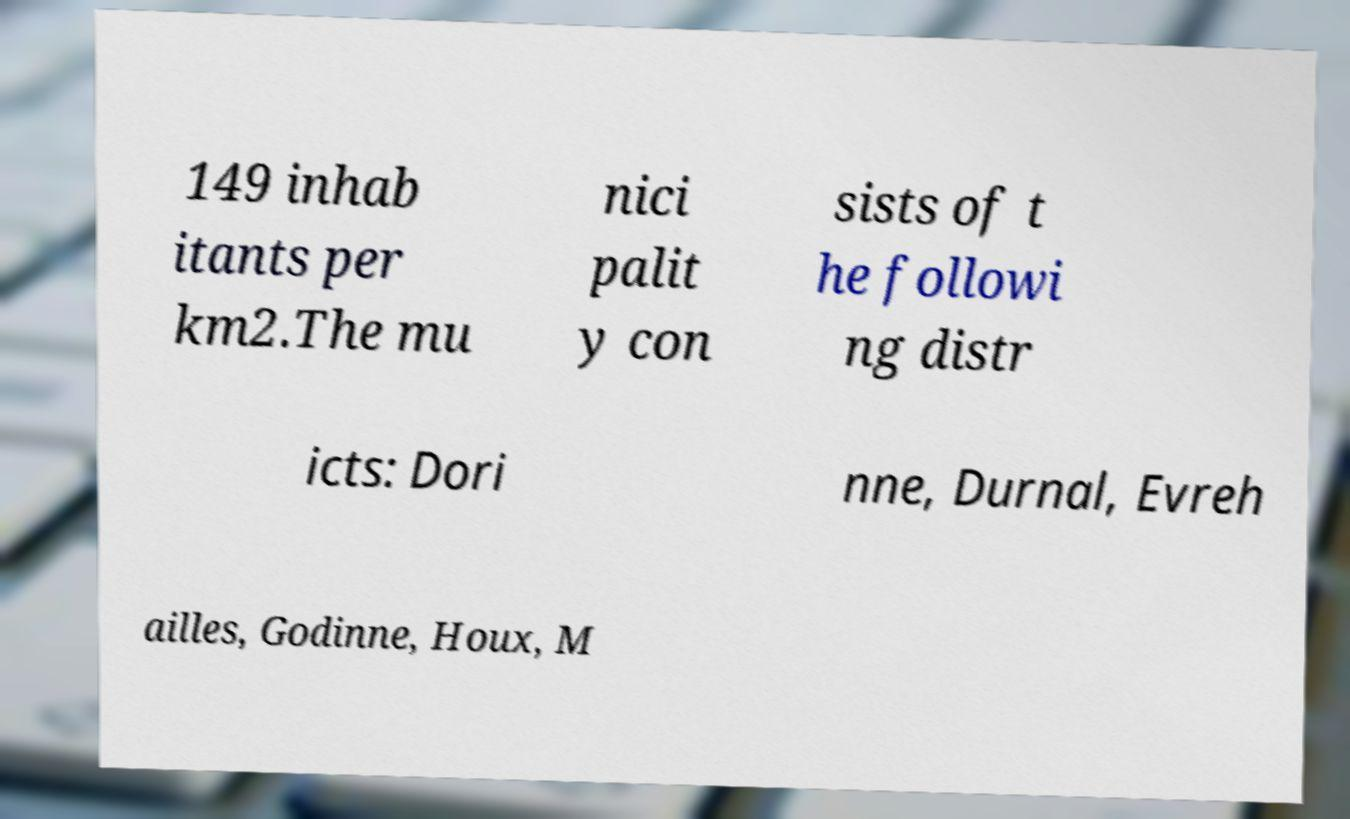Can you read and provide the text displayed in the image?This photo seems to have some interesting text. Can you extract and type it out for me? 149 inhab itants per km2.The mu nici palit y con sists of t he followi ng distr icts: Dori nne, Durnal, Evreh ailles, Godinne, Houx, M 